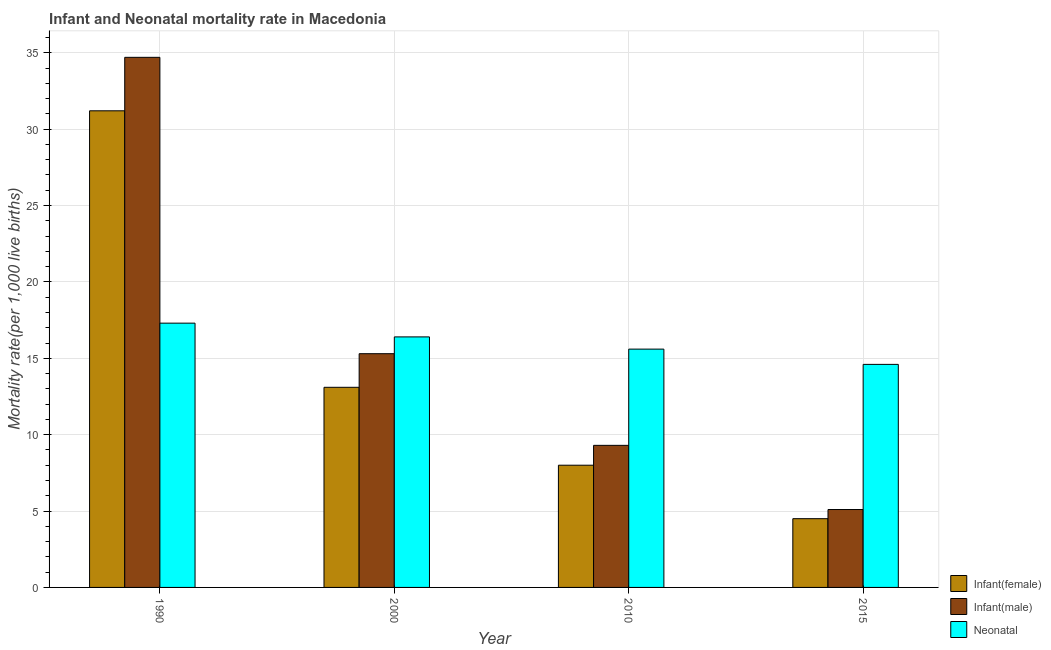How many different coloured bars are there?
Make the answer very short. 3. Are the number of bars on each tick of the X-axis equal?
Ensure brevity in your answer.  Yes. What is the label of the 3rd group of bars from the left?
Offer a very short reply. 2010. In how many cases, is the number of bars for a given year not equal to the number of legend labels?
Ensure brevity in your answer.  0. What is the infant mortality rate(male) in 2010?
Your answer should be compact. 9.3. Across all years, what is the maximum infant mortality rate(male)?
Your answer should be very brief. 34.7. In which year was the infant mortality rate(male) maximum?
Ensure brevity in your answer.  1990. In which year was the infant mortality rate(female) minimum?
Ensure brevity in your answer.  2015. What is the total neonatal mortality rate in the graph?
Your response must be concise. 63.9. What is the difference between the infant mortality rate(male) in 1990 and that in 2010?
Make the answer very short. 25.4. What is the average neonatal mortality rate per year?
Offer a terse response. 15.98. In the year 2010, what is the difference between the neonatal mortality rate and infant mortality rate(male)?
Make the answer very short. 0. What is the ratio of the infant mortality rate(female) in 1990 to that in 2000?
Provide a succinct answer. 2.38. Is the neonatal mortality rate in 1990 less than that in 2015?
Give a very brief answer. No. Is the difference between the infant mortality rate(male) in 1990 and 2015 greater than the difference between the infant mortality rate(female) in 1990 and 2015?
Ensure brevity in your answer.  No. What is the difference between the highest and the second highest neonatal mortality rate?
Ensure brevity in your answer.  0.9. What is the difference between the highest and the lowest infant mortality rate(male)?
Your response must be concise. 29.6. What does the 2nd bar from the left in 2010 represents?
Offer a terse response. Infant(male). What does the 2nd bar from the right in 2010 represents?
Offer a terse response. Infant(male). How many bars are there?
Provide a succinct answer. 12. Are all the bars in the graph horizontal?
Offer a terse response. No. How many years are there in the graph?
Provide a succinct answer. 4. Does the graph contain grids?
Offer a very short reply. Yes. How many legend labels are there?
Your answer should be compact. 3. How are the legend labels stacked?
Keep it short and to the point. Vertical. What is the title of the graph?
Your answer should be compact. Infant and Neonatal mortality rate in Macedonia. What is the label or title of the X-axis?
Offer a very short reply. Year. What is the label or title of the Y-axis?
Provide a succinct answer. Mortality rate(per 1,0 live births). What is the Mortality rate(per 1,000 live births) of Infant(female) in 1990?
Give a very brief answer. 31.2. What is the Mortality rate(per 1,000 live births) of Infant(male) in 1990?
Your response must be concise. 34.7. What is the Mortality rate(per 1,000 live births) of Neonatal  in 1990?
Offer a terse response. 17.3. What is the Mortality rate(per 1,000 live births) of Infant(female) in 2000?
Your response must be concise. 13.1. What is the Mortality rate(per 1,000 live births) of Infant(male) in 2000?
Offer a terse response. 15.3. What is the Mortality rate(per 1,000 live births) of Infant(female) in 2010?
Provide a succinct answer. 8. What is the Mortality rate(per 1,000 live births) in Infant(male) in 2010?
Provide a succinct answer. 9.3. What is the Mortality rate(per 1,000 live births) in Infant(male) in 2015?
Your answer should be compact. 5.1. What is the Mortality rate(per 1,000 live births) in Neonatal  in 2015?
Your answer should be compact. 14.6. Across all years, what is the maximum Mortality rate(per 1,000 live births) in Infant(female)?
Make the answer very short. 31.2. Across all years, what is the maximum Mortality rate(per 1,000 live births) in Infant(male)?
Make the answer very short. 34.7. What is the total Mortality rate(per 1,000 live births) in Infant(female) in the graph?
Your answer should be compact. 56.8. What is the total Mortality rate(per 1,000 live births) of Infant(male) in the graph?
Your answer should be compact. 64.4. What is the total Mortality rate(per 1,000 live births) in Neonatal  in the graph?
Provide a succinct answer. 63.9. What is the difference between the Mortality rate(per 1,000 live births) of Infant(female) in 1990 and that in 2000?
Offer a very short reply. 18.1. What is the difference between the Mortality rate(per 1,000 live births) of Infant(male) in 1990 and that in 2000?
Provide a short and direct response. 19.4. What is the difference between the Mortality rate(per 1,000 live births) of Neonatal  in 1990 and that in 2000?
Provide a short and direct response. 0.9. What is the difference between the Mortality rate(per 1,000 live births) in Infant(female) in 1990 and that in 2010?
Provide a short and direct response. 23.2. What is the difference between the Mortality rate(per 1,000 live births) of Infant(male) in 1990 and that in 2010?
Provide a succinct answer. 25.4. What is the difference between the Mortality rate(per 1,000 live births) of Neonatal  in 1990 and that in 2010?
Provide a succinct answer. 1.7. What is the difference between the Mortality rate(per 1,000 live births) in Infant(female) in 1990 and that in 2015?
Offer a terse response. 26.7. What is the difference between the Mortality rate(per 1,000 live births) of Infant(male) in 1990 and that in 2015?
Your response must be concise. 29.6. What is the difference between the Mortality rate(per 1,000 live births) of Neonatal  in 1990 and that in 2015?
Provide a short and direct response. 2.7. What is the difference between the Mortality rate(per 1,000 live births) in Infant(female) in 2000 and that in 2010?
Your response must be concise. 5.1. What is the difference between the Mortality rate(per 1,000 live births) of Infant(male) in 2000 and that in 2010?
Make the answer very short. 6. What is the difference between the Mortality rate(per 1,000 live births) in Infant(female) in 2000 and that in 2015?
Give a very brief answer. 8.6. What is the difference between the Mortality rate(per 1,000 live births) in Infant(male) in 2000 and that in 2015?
Offer a terse response. 10.2. What is the difference between the Mortality rate(per 1,000 live births) of Infant(male) in 2010 and that in 2015?
Provide a succinct answer. 4.2. What is the difference between the Mortality rate(per 1,000 live births) in Infant(male) in 1990 and the Mortality rate(per 1,000 live births) in Neonatal  in 2000?
Keep it short and to the point. 18.3. What is the difference between the Mortality rate(per 1,000 live births) in Infant(female) in 1990 and the Mortality rate(per 1,000 live births) in Infant(male) in 2010?
Keep it short and to the point. 21.9. What is the difference between the Mortality rate(per 1,000 live births) in Infant(female) in 1990 and the Mortality rate(per 1,000 live births) in Neonatal  in 2010?
Your answer should be very brief. 15.6. What is the difference between the Mortality rate(per 1,000 live births) of Infant(female) in 1990 and the Mortality rate(per 1,000 live births) of Infant(male) in 2015?
Offer a very short reply. 26.1. What is the difference between the Mortality rate(per 1,000 live births) in Infant(female) in 1990 and the Mortality rate(per 1,000 live births) in Neonatal  in 2015?
Provide a succinct answer. 16.6. What is the difference between the Mortality rate(per 1,000 live births) in Infant(male) in 1990 and the Mortality rate(per 1,000 live births) in Neonatal  in 2015?
Offer a very short reply. 20.1. What is the difference between the Mortality rate(per 1,000 live births) in Infant(female) in 2000 and the Mortality rate(per 1,000 live births) in Neonatal  in 2010?
Keep it short and to the point. -2.5. What is the difference between the Mortality rate(per 1,000 live births) of Infant(male) in 2000 and the Mortality rate(per 1,000 live births) of Neonatal  in 2010?
Keep it short and to the point. -0.3. What is the difference between the Mortality rate(per 1,000 live births) in Infant(female) in 2000 and the Mortality rate(per 1,000 live births) in Neonatal  in 2015?
Offer a very short reply. -1.5. What is the difference between the Mortality rate(per 1,000 live births) of Infant(male) in 2000 and the Mortality rate(per 1,000 live births) of Neonatal  in 2015?
Your response must be concise. 0.7. What is the average Mortality rate(per 1,000 live births) in Infant(female) per year?
Your response must be concise. 14.2. What is the average Mortality rate(per 1,000 live births) in Infant(male) per year?
Provide a succinct answer. 16.1. What is the average Mortality rate(per 1,000 live births) of Neonatal  per year?
Your answer should be very brief. 15.97. In the year 1990, what is the difference between the Mortality rate(per 1,000 live births) in Infant(female) and Mortality rate(per 1,000 live births) in Infant(male)?
Offer a terse response. -3.5. In the year 1990, what is the difference between the Mortality rate(per 1,000 live births) in Infant(female) and Mortality rate(per 1,000 live births) in Neonatal ?
Your answer should be very brief. 13.9. In the year 2000, what is the difference between the Mortality rate(per 1,000 live births) of Infant(female) and Mortality rate(per 1,000 live births) of Infant(male)?
Ensure brevity in your answer.  -2.2. In the year 2000, what is the difference between the Mortality rate(per 1,000 live births) of Infant(male) and Mortality rate(per 1,000 live births) of Neonatal ?
Your answer should be compact. -1.1. In the year 2010, what is the difference between the Mortality rate(per 1,000 live births) in Infant(female) and Mortality rate(per 1,000 live births) in Infant(male)?
Provide a succinct answer. -1.3. In the year 2010, what is the difference between the Mortality rate(per 1,000 live births) in Infant(male) and Mortality rate(per 1,000 live births) in Neonatal ?
Offer a very short reply. -6.3. What is the ratio of the Mortality rate(per 1,000 live births) in Infant(female) in 1990 to that in 2000?
Keep it short and to the point. 2.38. What is the ratio of the Mortality rate(per 1,000 live births) in Infant(male) in 1990 to that in 2000?
Offer a terse response. 2.27. What is the ratio of the Mortality rate(per 1,000 live births) in Neonatal  in 1990 to that in 2000?
Your response must be concise. 1.05. What is the ratio of the Mortality rate(per 1,000 live births) of Infant(male) in 1990 to that in 2010?
Make the answer very short. 3.73. What is the ratio of the Mortality rate(per 1,000 live births) of Neonatal  in 1990 to that in 2010?
Ensure brevity in your answer.  1.11. What is the ratio of the Mortality rate(per 1,000 live births) of Infant(female) in 1990 to that in 2015?
Offer a terse response. 6.93. What is the ratio of the Mortality rate(per 1,000 live births) of Infant(male) in 1990 to that in 2015?
Provide a short and direct response. 6.8. What is the ratio of the Mortality rate(per 1,000 live births) in Neonatal  in 1990 to that in 2015?
Give a very brief answer. 1.18. What is the ratio of the Mortality rate(per 1,000 live births) of Infant(female) in 2000 to that in 2010?
Offer a very short reply. 1.64. What is the ratio of the Mortality rate(per 1,000 live births) in Infant(male) in 2000 to that in 2010?
Your answer should be compact. 1.65. What is the ratio of the Mortality rate(per 1,000 live births) of Neonatal  in 2000 to that in 2010?
Your answer should be compact. 1.05. What is the ratio of the Mortality rate(per 1,000 live births) in Infant(female) in 2000 to that in 2015?
Your answer should be very brief. 2.91. What is the ratio of the Mortality rate(per 1,000 live births) in Neonatal  in 2000 to that in 2015?
Your answer should be compact. 1.12. What is the ratio of the Mortality rate(per 1,000 live births) in Infant(female) in 2010 to that in 2015?
Your answer should be compact. 1.78. What is the ratio of the Mortality rate(per 1,000 live births) of Infant(male) in 2010 to that in 2015?
Give a very brief answer. 1.82. What is the ratio of the Mortality rate(per 1,000 live births) of Neonatal  in 2010 to that in 2015?
Give a very brief answer. 1.07. What is the difference between the highest and the second highest Mortality rate(per 1,000 live births) in Infant(female)?
Your answer should be very brief. 18.1. What is the difference between the highest and the second highest Mortality rate(per 1,000 live births) in Infant(male)?
Your answer should be very brief. 19.4. What is the difference between the highest and the second highest Mortality rate(per 1,000 live births) in Neonatal ?
Your answer should be compact. 0.9. What is the difference between the highest and the lowest Mortality rate(per 1,000 live births) of Infant(female)?
Your answer should be compact. 26.7. What is the difference between the highest and the lowest Mortality rate(per 1,000 live births) of Infant(male)?
Offer a very short reply. 29.6. 